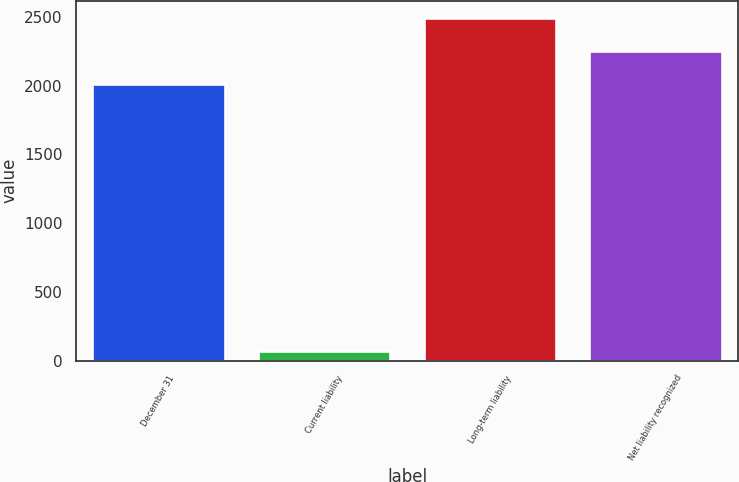Convert chart to OTSL. <chart><loc_0><loc_0><loc_500><loc_500><bar_chart><fcel>December 31<fcel>Current liability<fcel>Long-term liability<fcel>Net liability recognized<nl><fcel>2011<fcel>68<fcel>2494.2<fcel>2252.6<nl></chart> 